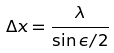<formula> <loc_0><loc_0><loc_500><loc_500>\Delta x = \frac { \lambda } { \sin \epsilon / 2 }</formula> 